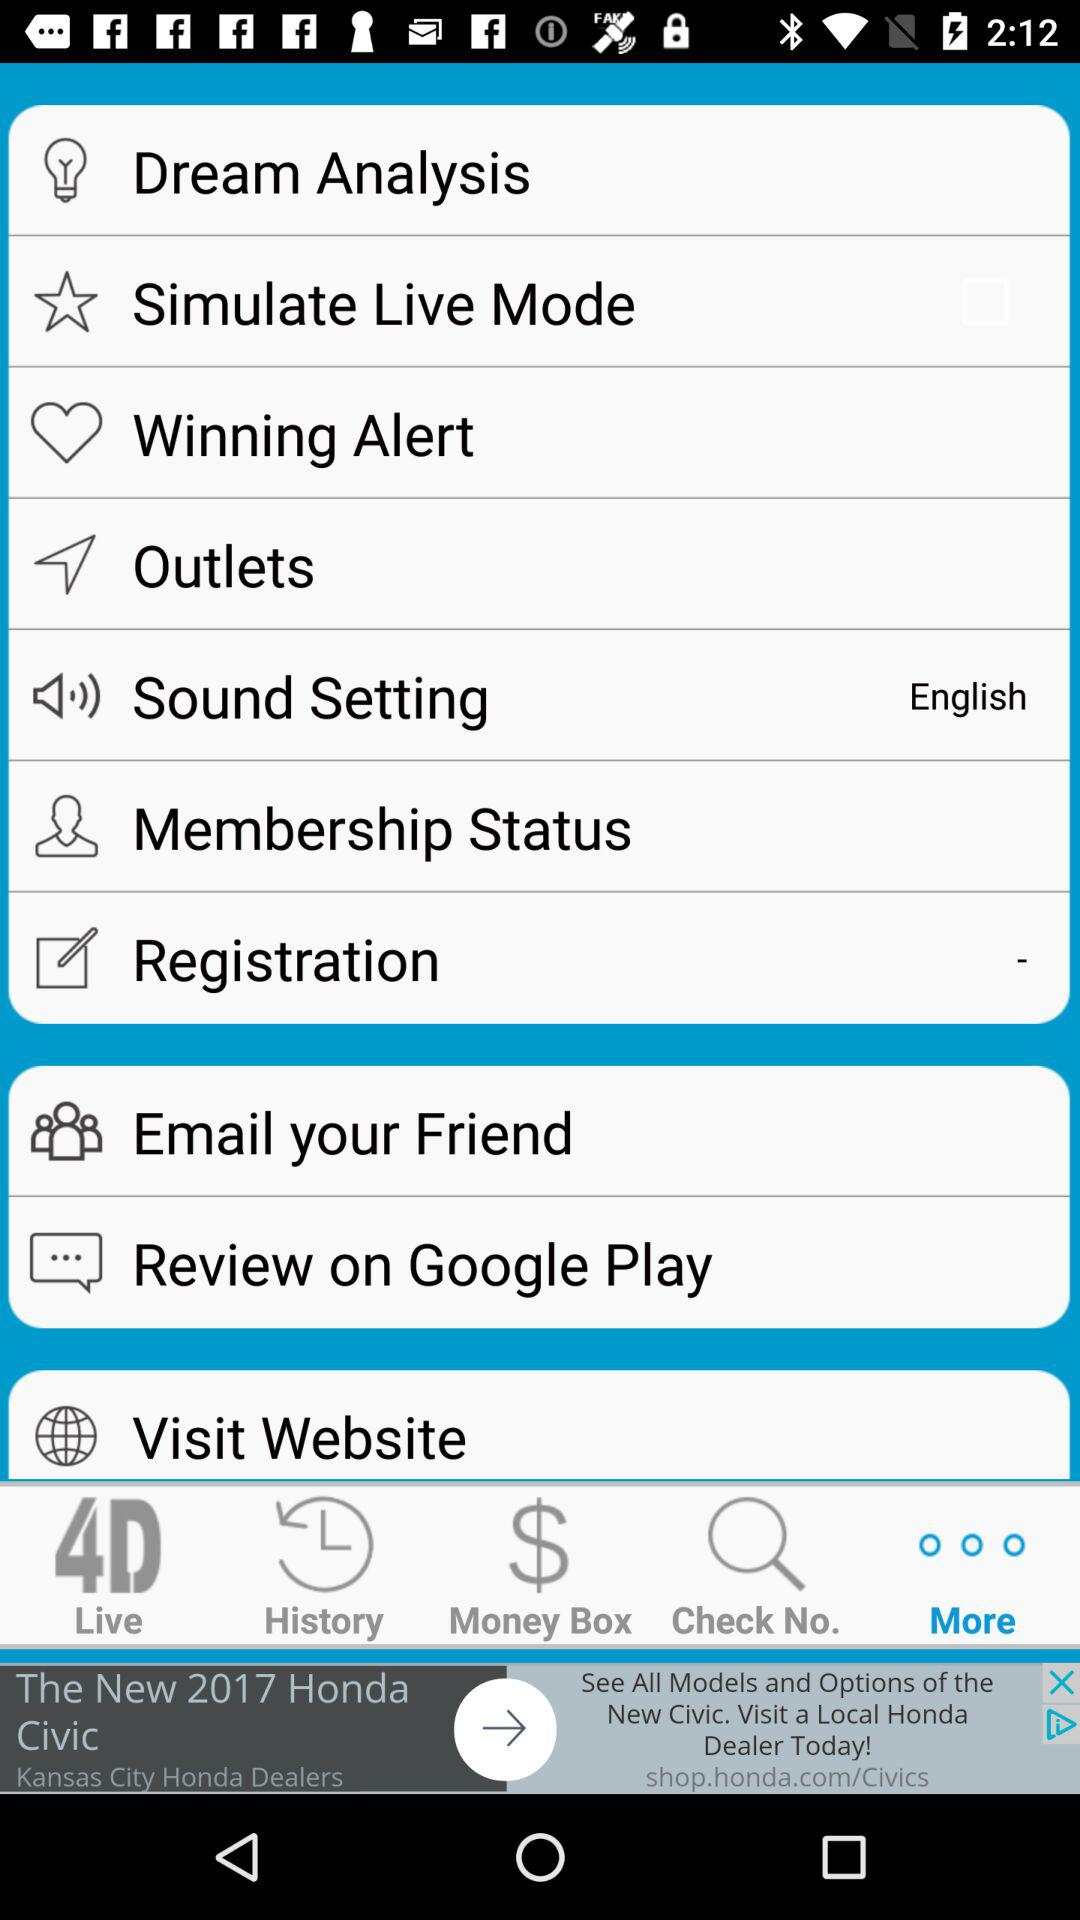Which tab is selected? The selected tab is "More". 